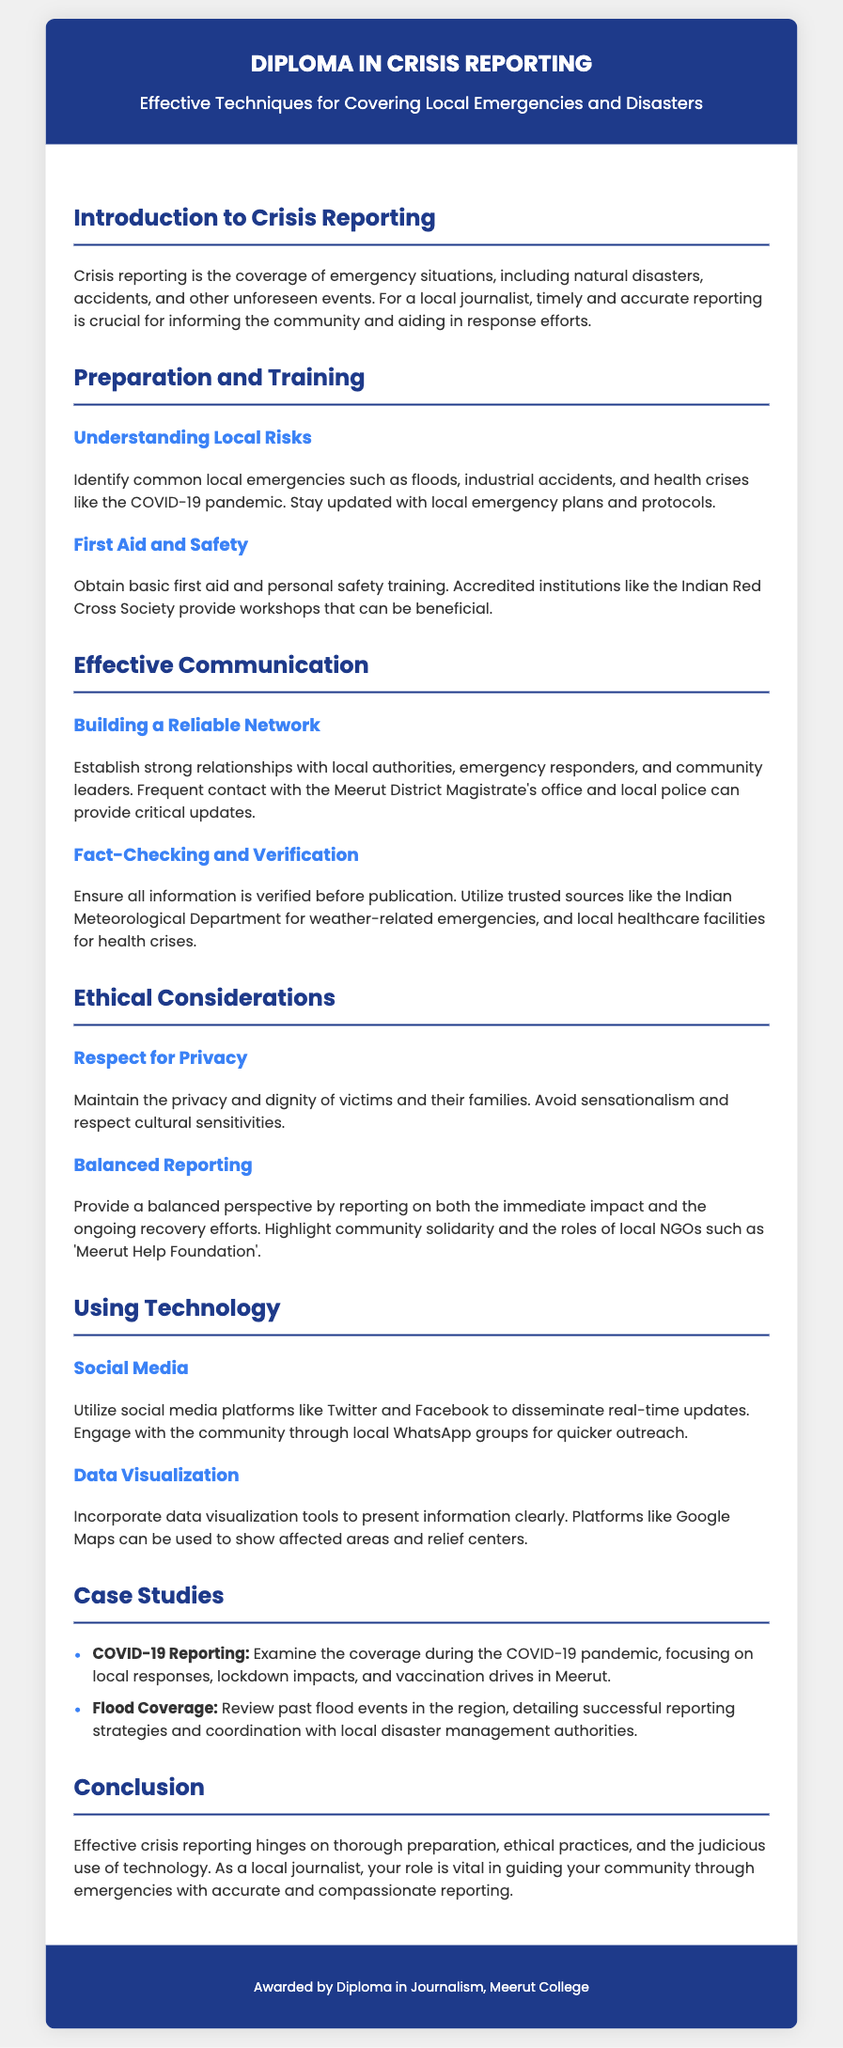what is the title of the diploma? The title is mentioned in the header section of the document, which reads "Diploma in Crisis Reporting."
Answer: Diploma in Crisis Reporting what is the main focus of the diploma? The subtitle provides insight into the primary goal, which is to cover local emergencies and disasters effectively.
Answer: Effective Techniques for Covering Local Emergencies and Disasters which organization offers training for first aid mentioned in the document? The document mentions "the Indian Red Cross Society" as an accredited institution for first aid training.
Answer: Indian Red Cross Society what are the two social media platforms suggested for real-time updates? The document lists specific platforms that can be used for communication, namely "Twitter and Facebook."
Answer: Twitter and Facebook what is one ethical consideration mentioned in the document? To address ethical practices, the document highlights the importance of respecting the privacy and dignity of victims.
Answer: Respect for Privacy how many case studies are presented in the document? The section titled "Case Studies" lists two specific case studies related to crisis reporting.
Answer: Two which local NGO is highlighted for its role in community solidarity? The document mentions "Meerut Help Foundation" as a local NGO focusing on community support during crises.
Answer: Meerut Help Foundation what is emphasized as crucial for effective crisis reporting in the conclusion? The conclusion underscores the importance of thorough preparation, ethical practices, and technology use in crisis reporting.
Answer: Thorough preparation, ethical practices, and technology use 